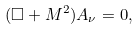Convert formula to latex. <formula><loc_0><loc_0><loc_500><loc_500>( \Box + M ^ { 2 } ) A _ { \nu } = 0 ,</formula> 